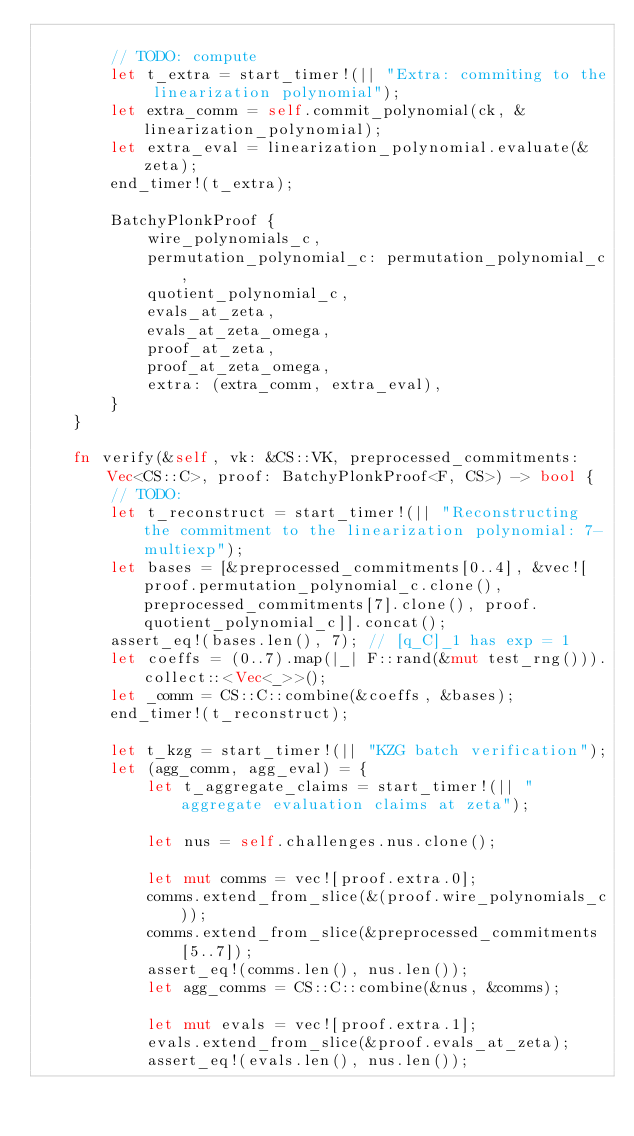<code> <loc_0><loc_0><loc_500><loc_500><_Rust_>
        // TODO: compute
        let t_extra = start_timer!(|| "Extra: commiting to the linearization polynomial");
        let extra_comm = self.commit_polynomial(ck, &linearization_polynomial);
        let extra_eval = linearization_polynomial.evaluate(&zeta);
        end_timer!(t_extra);

        BatchyPlonkProof {
            wire_polynomials_c,
            permutation_polynomial_c: permutation_polynomial_c,
            quotient_polynomial_c,
            evals_at_zeta,
            evals_at_zeta_omega,
            proof_at_zeta,
            proof_at_zeta_omega,
            extra: (extra_comm, extra_eval),
        }
    }

    fn verify(&self, vk: &CS::VK, preprocessed_commitments: Vec<CS::C>, proof: BatchyPlonkProof<F, CS>) -> bool {
        // TODO:
        let t_reconstruct = start_timer!(|| "Reconstructing the commitment to the linearization polynomial: 7-multiexp");
        let bases = [&preprocessed_commitments[0..4], &vec![proof.permutation_polynomial_c.clone(), preprocessed_commitments[7].clone(), proof.quotient_polynomial_c]].concat();
        assert_eq!(bases.len(), 7); // [q_C]_1 has exp = 1
        let coeffs = (0..7).map(|_| F::rand(&mut test_rng())).collect::<Vec<_>>();
        let _comm = CS::C::combine(&coeffs, &bases);
        end_timer!(t_reconstruct);

        let t_kzg = start_timer!(|| "KZG batch verification");
        let (agg_comm, agg_eval) = {
            let t_aggregate_claims = start_timer!(|| "aggregate evaluation claims at zeta");

            let nus = self.challenges.nus.clone();

            let mut comms = vec![proof.extra.0];
            comms.extend_from_slice(&(proof.wire_polynomials_c));
            comms.extend_from_slice(&preprocessed_commitments[5..7]);
            assert_eq!(comms.len(), nus.len());
            let agg_comms = CS::C::combine(&nus, &comms);

            let mut evals = vec![proof.extra.1];
            evals.extend_from_slice(&proof.evals_at_zeta);
            assert_eq!(evals.len(), nus.len());</code> 